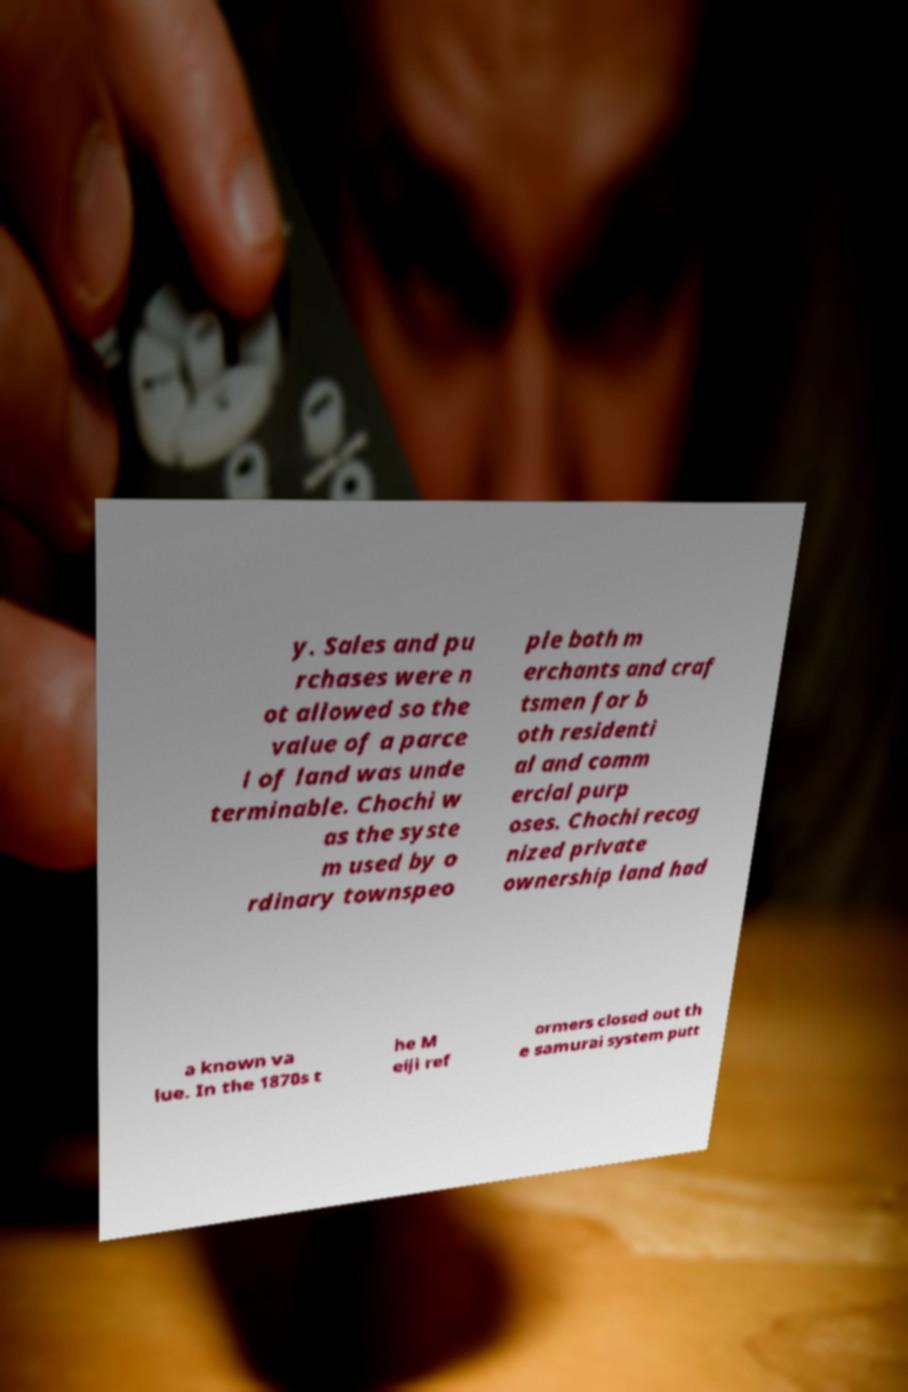Can you accurately transcribe the text from the provided image for me? y. Sales and pu rchases were n ot allowed so the value of a parce l of land was unde terminable. Chochi w as the syste m used by o rdinary townspeo ple both m erchants and craf tsmen for b oth residenti al and comm ercial purp oses. Chochi recog nized private ownership land had a known va lue. In the 1870s t he M eiji ref ormers closed out th e samurai system putt 